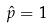<formula> <loc_0><loc_0><loc_500><loc_500>\hat { p } = 1</formula> 